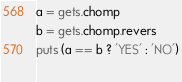<code> <loc_0><loc_0><loc_500><loc_500><_Ruby_>a = gets.chomp
b = gets.chomp.revers
puts (a == b ? 'YES' : 'NO')
  
</code> 